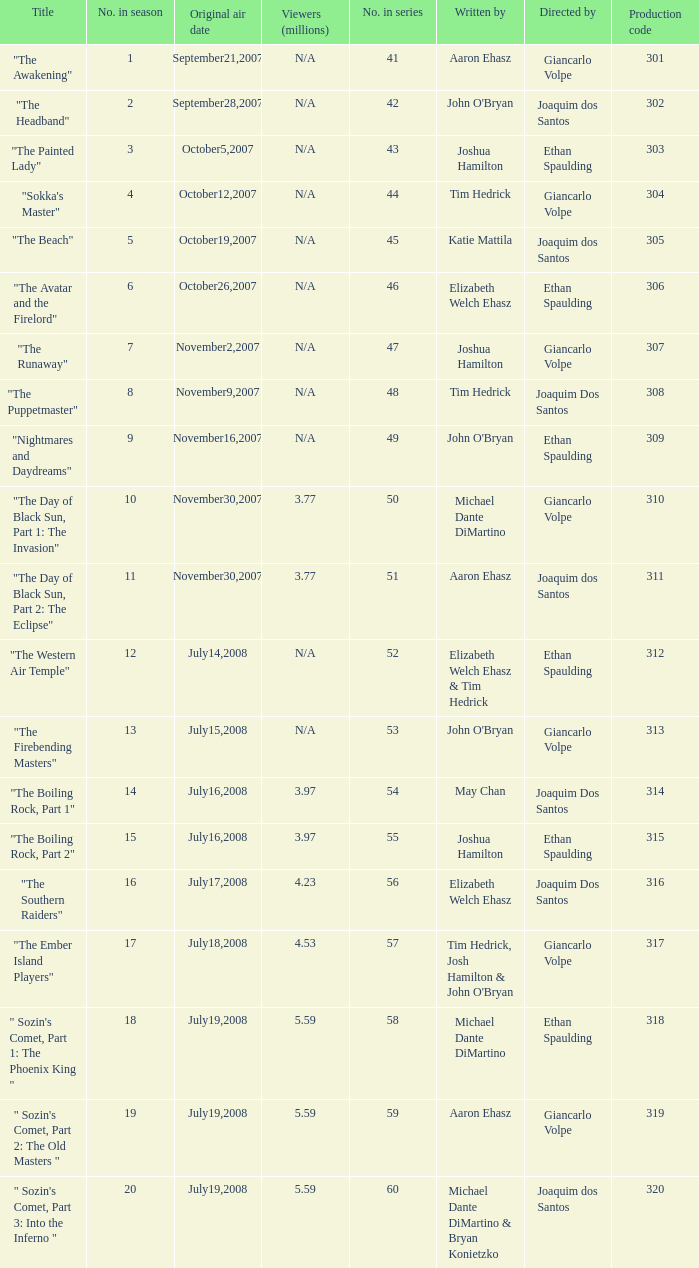How many viewers in millions for episode "sokka's master"? N/A. 